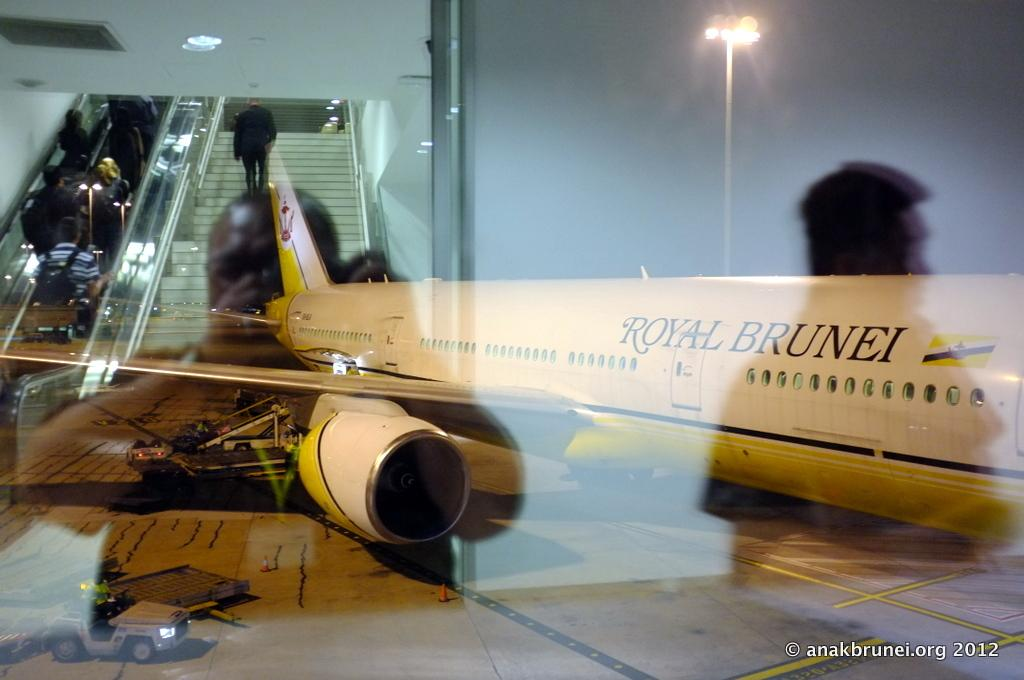<image>
Provide a brief description of the given image. A Royal Brunei airplane sitting at an airport 